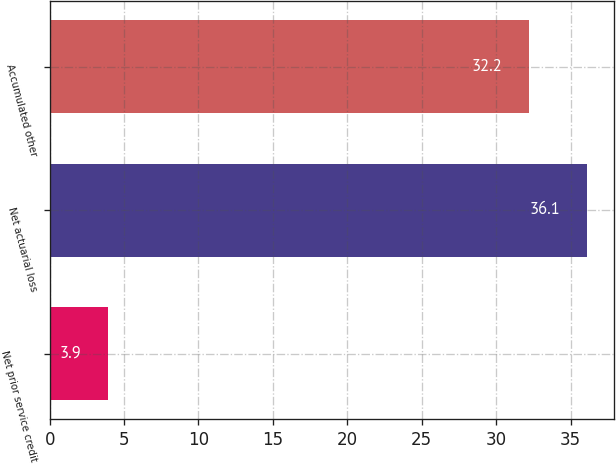Convert chart to OTSL. <chart><loc_0><loc_0><loc_500><loc_500><bar_chart><fcel>Net prior service credit<fcel>Net actuarial loss<fcel>Accumulated other<nl><fcel>3.9<fcel>36.1<fcel>32.2<nl></chart> 